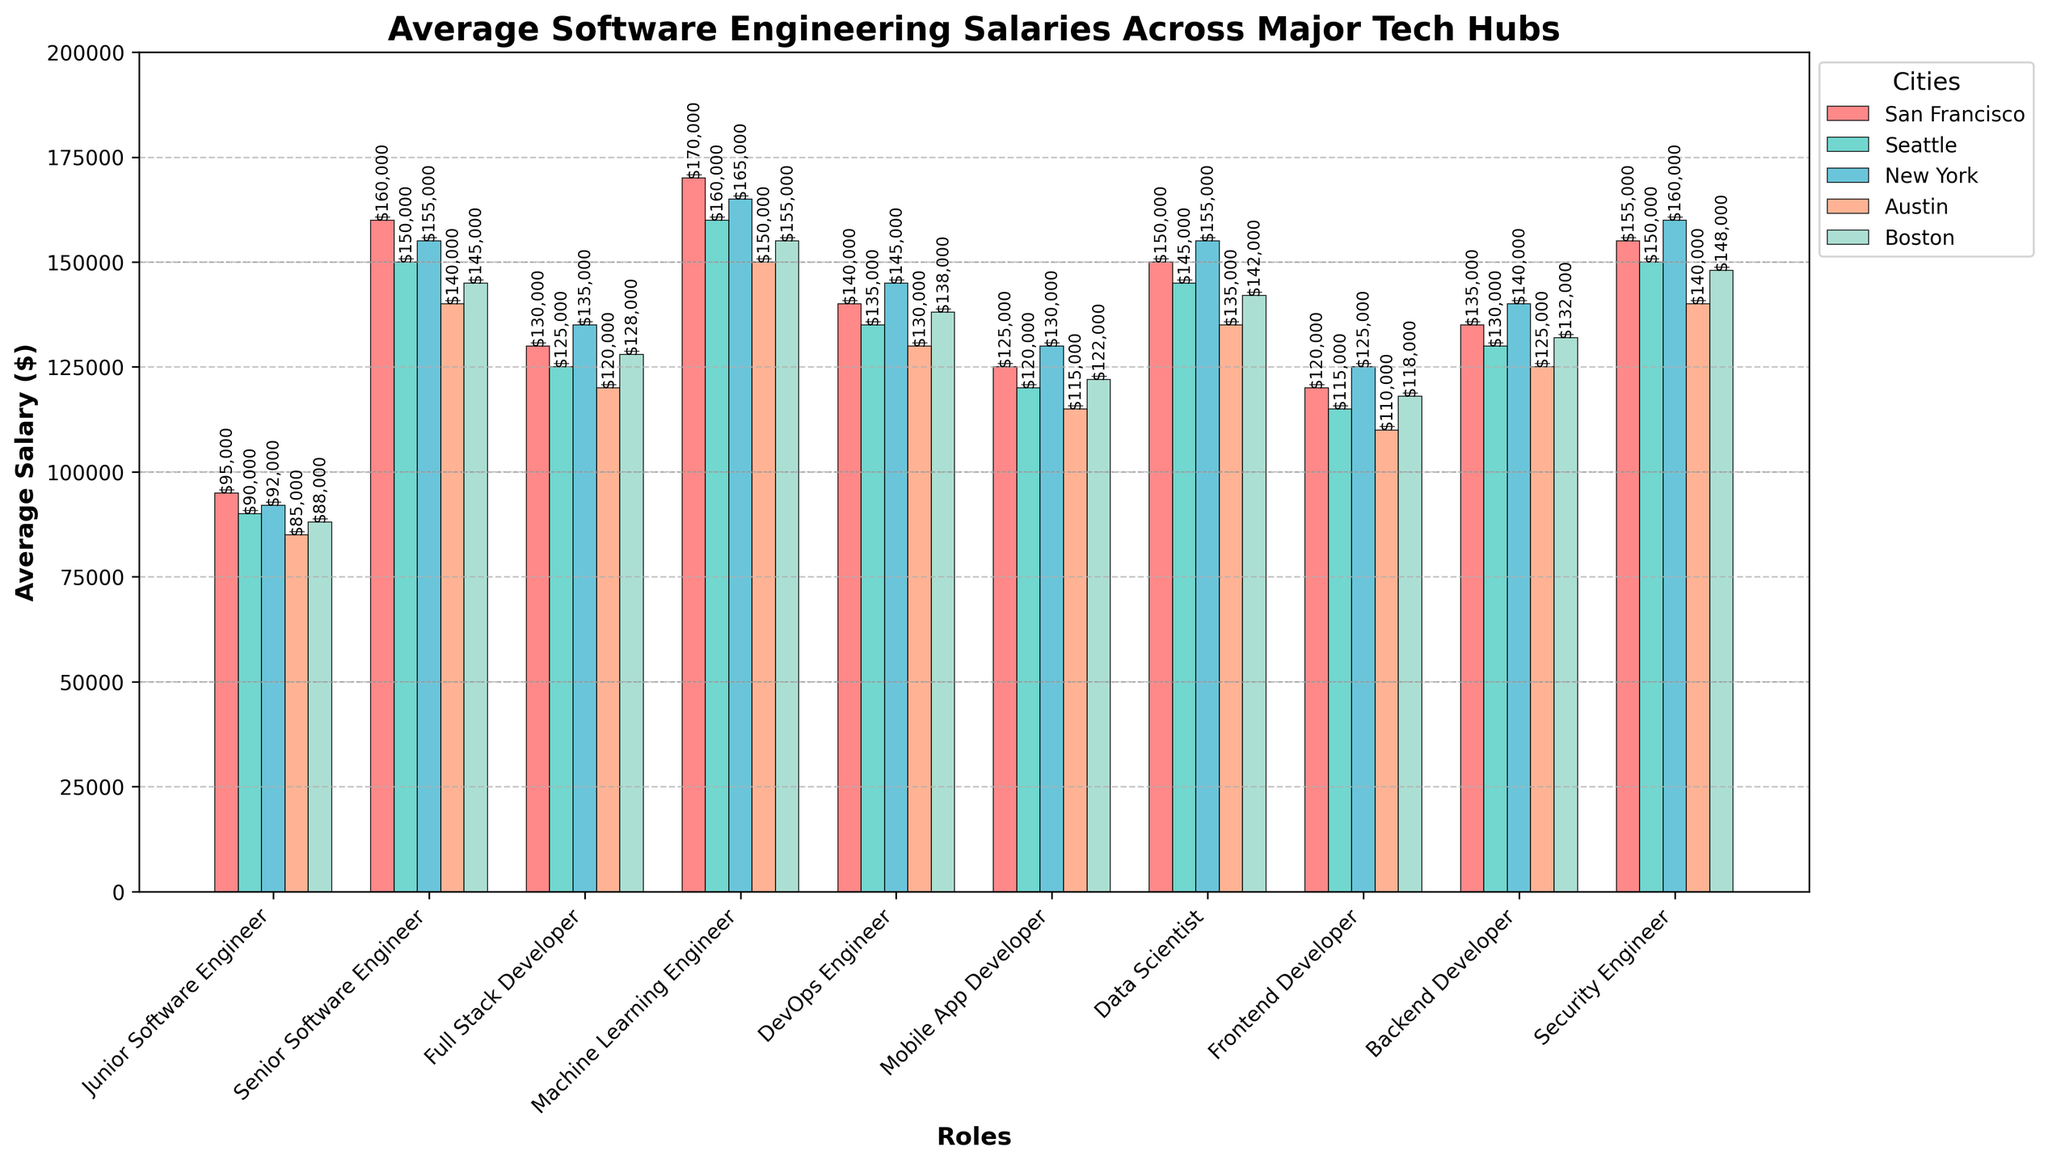What's the highest average salary for a Machine Learning Engineer? Look at the bar corresponding to the role "Machine Learning Engineer" across all cities. The highest bar represents the highest average salary, which is in San Francisco.
Answer: San Francisco Which city has the lowest average salary for a Data Scientist? Observe the bars corresponding to "Data Scientist" and identify the city with the smallest bar height. Austin's bar for this role is the lowest.
Answer: Austin What is the difference between the highest and lowest average salary for a Senior Software Engineer? Find the heights of the bars for "Senior Software Engineer" in all cities. The highest is in San Francisco ($160,000), and the lowest is in Austin ($140,000). Subtract the lowest from the highest: $160,000 - $140,000 = $20,000.
Answer: $20,000 What is the combined average salary for a Junior Software Engineer in San Francisco and Seattle? Identify the salary of "Junior Software Engineer" in San Francisco ($95,000) and Seattle ($90,000). Add these values together: $95,000 + $90,000 = $185,000.
Answer: $185,000 Which role has the most consistent (or least variable) salary across all cities? Compare the variation in the heights of the bars for each role across all cities. Full Stack Developer has relatively even bars with little variation.
Answer: Full Stack Developer Which city offers higher average salaries for DevOps Engineers: Boston or Austin? Compare the height of the bars for "DevOps Engineer" in Boston and Austin. Boston has a slightly higher bar ($138,000) compared to Austin ($130,000).
Answer: Boston What's the average salary of a Mobile App Developer across all cities? Add the salaries of "Mobile App Developer" in all cities and divide by the number of cities: ($125,000 + $120,000 + $130,000 + $115,000 + $122,000) ÷ 5 = $122,400.
Answer: $122,400 Which role in Seattle slightly surpasses a salary of $150,000? Look at the bars for each role in Seattle that are around $150,000. The "Senior Software Engineer" (with $150,000) and "Security Engineer" ($150,000) both fall into this category.
Answer: Senior Software Engineer, Security Engineer What is the average salary for Backend Developers in the three highest-paying cities? Identify the three highest-paying cities for "Backend Developer": New York ($140,000), San Francisco ($135,000), and Boston ($132,000). Calculate the average: ($140,000 + $135,000 + $132,000) ÷ 3 = $135,667.
Answer: $135,667 How does the average salary of a Frontend Developer in New York compare to that in Seattle? Observe the bars for "Frontend Developer" in New York and Seattle, where New York ($125,000) is higher compared to Seattle ($115,000).
Answer: New York is higher 